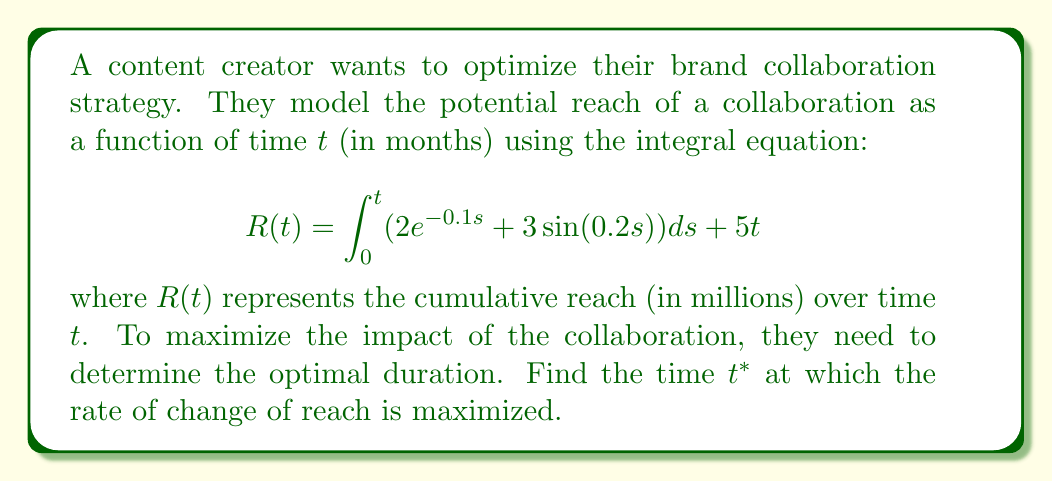Show me your answer to this math problem. To solve this problem, we need to follow these steps:

1) First, we need to find the rate of change of reach, which is the derivative of $R(t)$ with respect to $t$. Let's call this $R'(t)$.

2) To find $R'(t)$, we use the Fundamental Theorem of Calculus and the chain rule:

   $$R'(t) = \frac{d}{dt}\int_0^t (2e^{-0.1s} + 3\sin(0.2s))ds + \frac{d}{dt}(5t)$$
   
   $$R'(t) = 2e^{-0.1t} + 3\sin(0.2t) + 5$$

3) To find the maximum of $R'(t)$, we need to find where its derivative equals zero:

   $$R''(t) = -0.2e^{-0.1t} + 0.6\cos(0.2t) = 0$$

4) This equation is transcendental and cannot be solved algebraically. We need to use numerical methods to find the solution.

5) Using a numerical solver or graphing calculator, we can find that the first positive solution to this equation occurs at approximately $t^* \approx 4.97$ months.

6) To confirm this is a maximum (not a minimum), we can check the sign of $R'''(t)$ at this point:

   $$R'''(t) = 0.02e^{-0.1t} - 0.12\sin(0.2t)$$

   At $t^* \approx 4.97$, $R'''(t^*) < 0$, confirming it's a local maximum.

Therefore, the rate of change of reach is maximized at approximately 4.97 months.
Answer: $t^* \approx 4.97$ months 